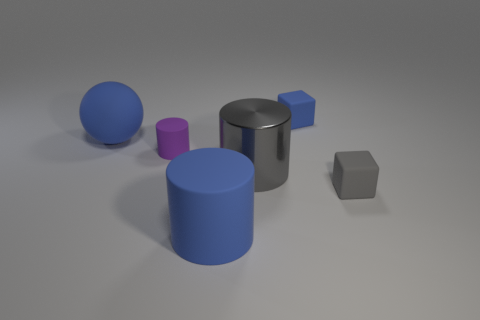Is there anything else that is the same material as the gray cylinder?
Offer a terse response. No. What material is the thing in front of the small matte block that is in front of the blue thing behind the rubber ball?
Make the answer very short. Rubber. Is the number of rubber objects that are in front of the tiny gray cube greater than the number of gray metal objects behind the large rubber sphere?
Make the answer very short. Yes. How many matte things are either blue spheres or cylinders?
Your answer should be very brief. 3. There is a large thing that is the same color as the big matte ball; what shape is it?
Your response must be concise. Cylinder. There is a block in front of the gray cylinder; what material is it?
Make the answer very short. Rubber. What number of things are either blue cubes or blue things that are to the left of the blue matte cylinder?
Make the answer very short. 2. There is a purple object that is the same size as the gray rubber object; what is its shape?
Keep it short and to the point. Cylinder. How many small matte objects have the same color as the shiny thing?
Keep it short and to the point. 1. Are the tiny cube that is behind the tiny gray block and the large gray cylinder made of the same material?
Ensure brevity in your answer.  No. 